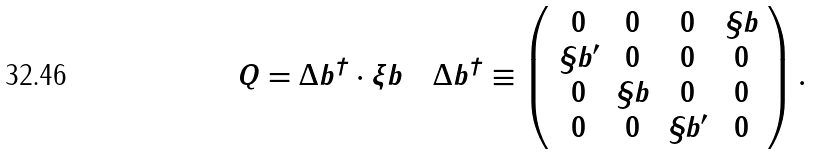<formula> <loc_0><loc_0><loc_500><loc_500>Q = \Delta b ^ { \dagger } \cdot \xi b \quad \Delta b ^ { \dagger } \equiv \left ( \begin{array} { c c c c } 0 & 0 & 0 & \S b \\ \S b ^ { \prime } & 0 & 0 & 0 \\ 0 & \S b & 0 & 0 \\ 0 & 0 & \S b ^ { \prime } & 0 \end{array} \right ) .</formula> 